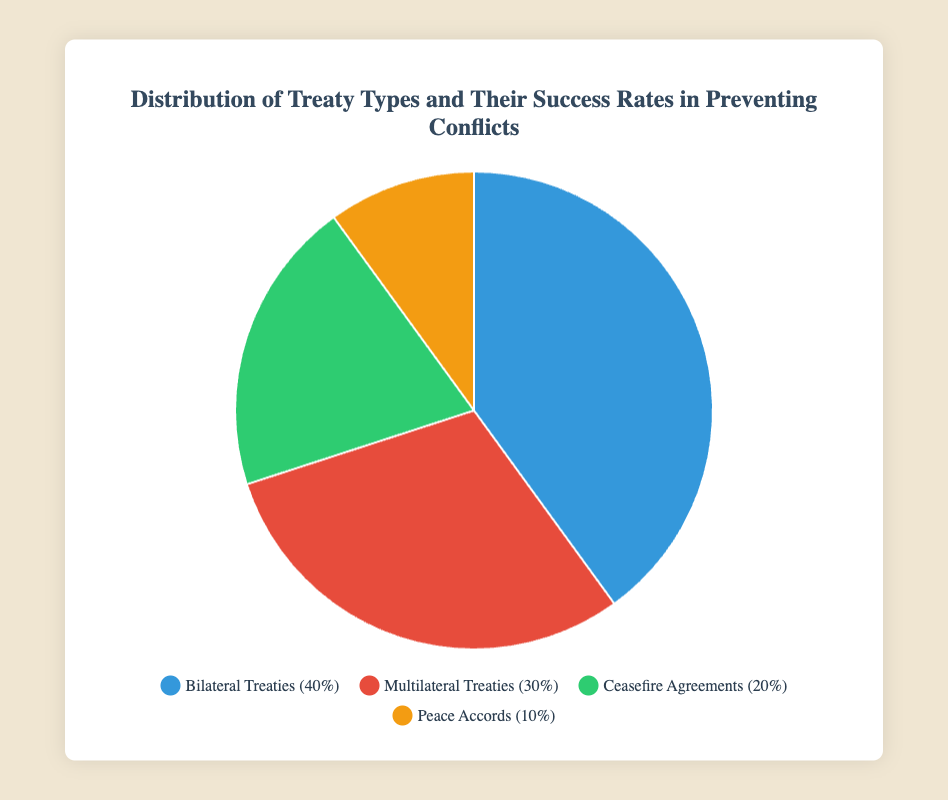Which treaty type has the highest success rate in preventing conflicts? From the pie chart, we look for the treaty with the highest success rate. "Peace Accords" stands out with an 80% success rate indicated in the tooltip.
Answer: Peace Accords Which treaty type occupies the largest segment of the pie chart? We examine the pie chart for the largest segment by area. The "Bilateral Treaties" segment clearly occupies the largest area.
Answer: Bilateral Treaties What is the difference in percentage between Bilateral Treaties and Multilateral Treaties? From the chart, Bilateral Treaties are 40% and Multilateral Treaties are 30%. The difference is 40% - 30% = 10%.
Answer: 10% Which two treaty types together make up the smallest proportion of the pie chart? We sum the smallest percentages: "Peace Accords" at 10% and "Ceasefire Agreements" at 20%. Together, they form the smallest proportion compared to other combinations.
Answer: Peace Accords and Ceasefire Agreements If a conflict is resolved by a treaty at random, what is the probability that it will be a Multilateral Treaty? To find the probability, we use the percentage of Multilateral Treaties, which is 30% as per the pie chart. Therefore, the probability is 30%.
Answer: 30% Among all treaty types, which has the lowest success rate in preventing conflicts? The chart shows success rates in tooltips. The "Ceasefire Agreements" have the lowest success rate at 50%.
Answer: Ceasefire Agreements How much more successful are Peace Accords compared to Ceasefire Agreements in percentage points? We compare their success rates: "Peace Accords" at 80% and "Ceasefire Agreements" at 50%. The difference is 80% - 50% = 30%.
Answer: 30% Which treaty type has the same color as Multilateral Treaties in the legend? The chart legend indicates that Multilateral Treaties are colored red. We confirm this by looking at other segments and their colors and seeing no overlaps.
Answer: Red What's the average success rate of Bilateral and Multilateral Treaties? To get the average, add the success rates of Bilateral (70%) and Multilateral (60%) treaties: 70 + 60 = 130. Then divide by 2: 130 / 2 = 65%.
Answer: 65% How much area in percentage do Ceasefire Agreements and Peace Accords together make in the pie chart? From the chart, "Ceasefire Agreements" cover 20% and "Peace Accords" cover 10%. Adding these together, we get 20% + 10% = 30%.
Answer: 30% 